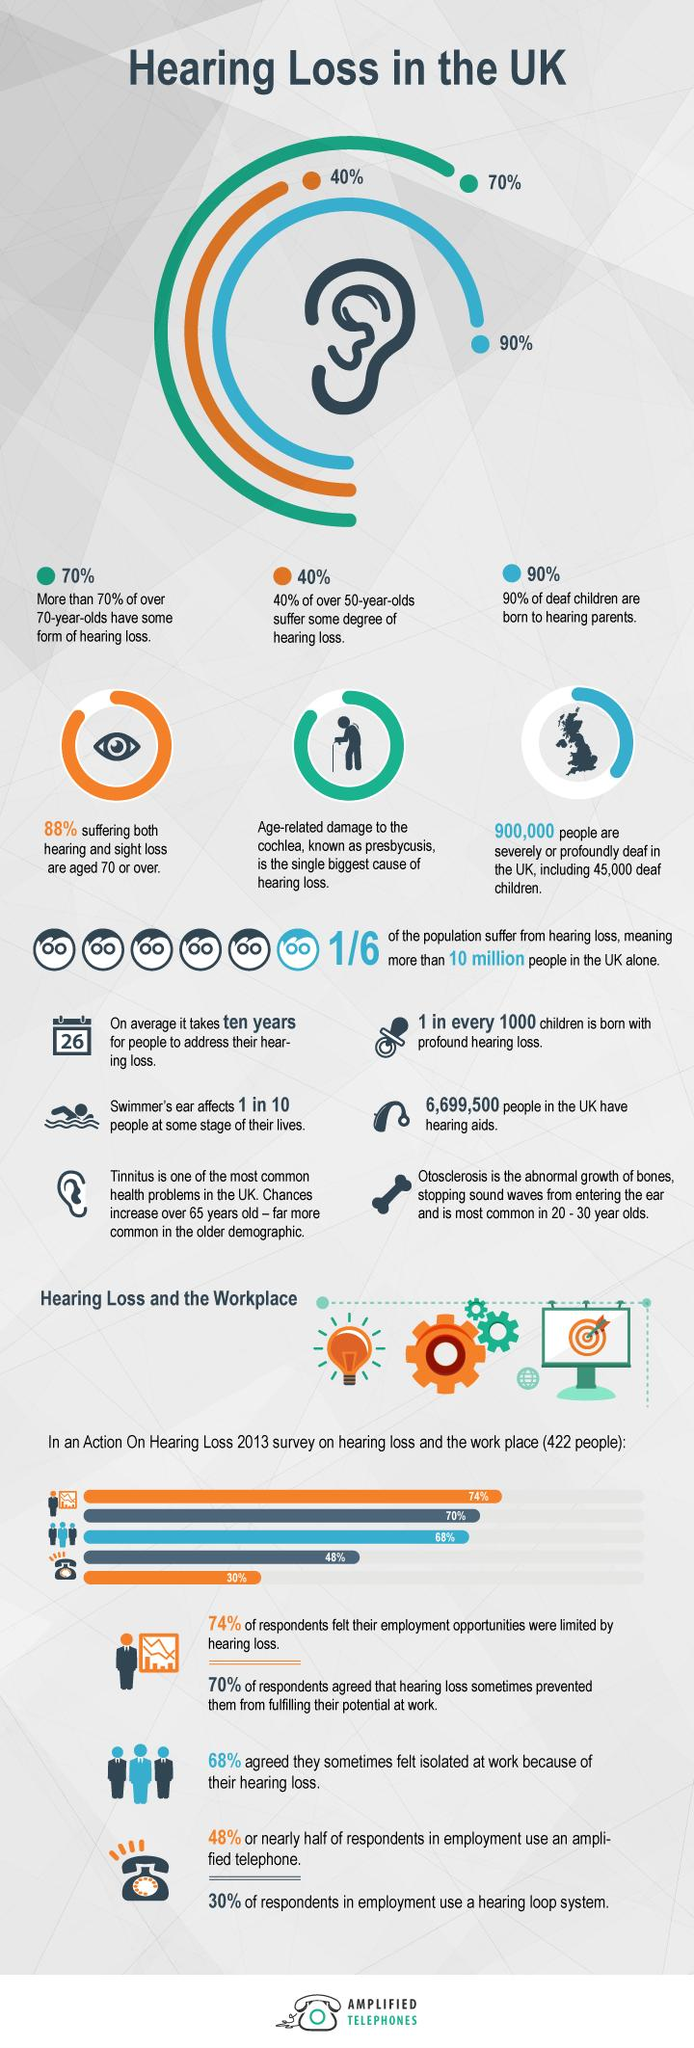Identify some key points in this picture. Otosclerosis is a hearing problem that can particularly affect the youth, resulting in difficulty hearing and understanding speech, especially in noisy environments. According to recent studies, only 0.10% of children are born with profound hearing loss. The main reason for hearing loss is the malfunction of the cochlea, which is a part of the ear. Presbycusis and tinnitus are two types of ear problems that can affect elderly individuals. According to recent estimates, approximately 10% of children born to deaf parents are also born deaf. 